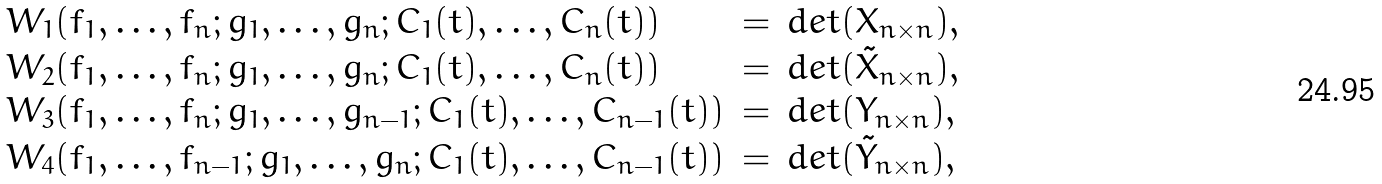<formula> <loc_0><loc_0><loc_500><loc_500>\begin{array} { l l l } W _ { 1 } ( f _ { 1 } , \dots , f _ { n } ; g _ { 1 } , \dots , g _ { n } ; C _ { 1 } ( t ) , \dots , C _ { n } ( t ) ) & = & d e t ( X _ { n \times n } ) , \\ W _ { 2 } ( f _ { 1 } , \dots , f _ { n } ; g _ { 1 } , \dots , g _ { n } ; C _ { 1 } ( t ) , \dots , C _ { n } ( t ) ) & = & d e t ( \tilde { X } _ { n \times n } ) , \\ W _ { 3 } ( f _ { 1 } , \dots , f _ { n } ; g _ { 1 } , \dots , g _ { n - 1 } ; C _ { 1 } ( t ) , \dots , C _ { n - 1 } ( t ) ) & = & d e t ( Y _ { n \times n } ) , \\ W _ { 4 } ( f _ { 1 } , \dots , f _ { n - 1 } ; g _ { 1 } , \dots , g _ { n } ; C _ { 1 } ( t ) , \dots , C _ { n - 1 } ( t ) ) & = & d e t ( \tilde { Y } _ { n \times n } ) , \end{array}</formula> 